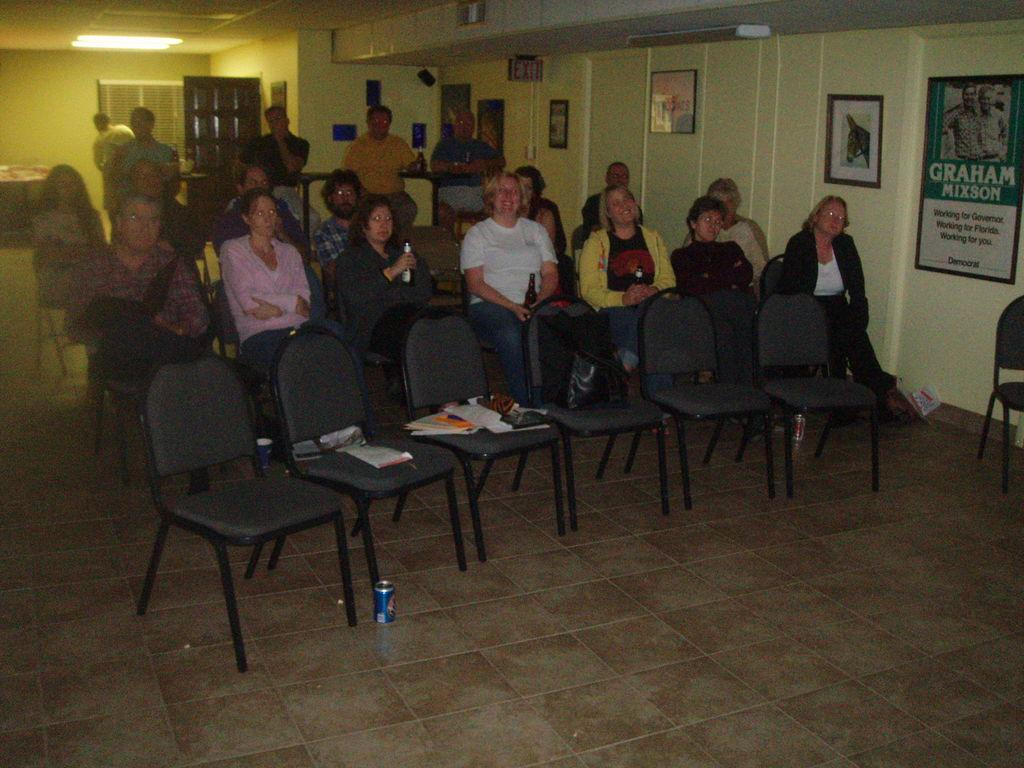Who or what can be seen in the image? There are people in the image. What objects are present for seating? There are chairs in the image. What items are related to reading or learning? There are books in the image. What type of background is visible? There is a wall in the image. What is hanging on the wall? There is a banner in the image. What might be used for displaying photos or artwork? There are photo frames in the image. What provides illumination in the image? There are lights in the image. What type of leather is being used to make the tax forms in the image? There is no leather or tax forms present in the image. 